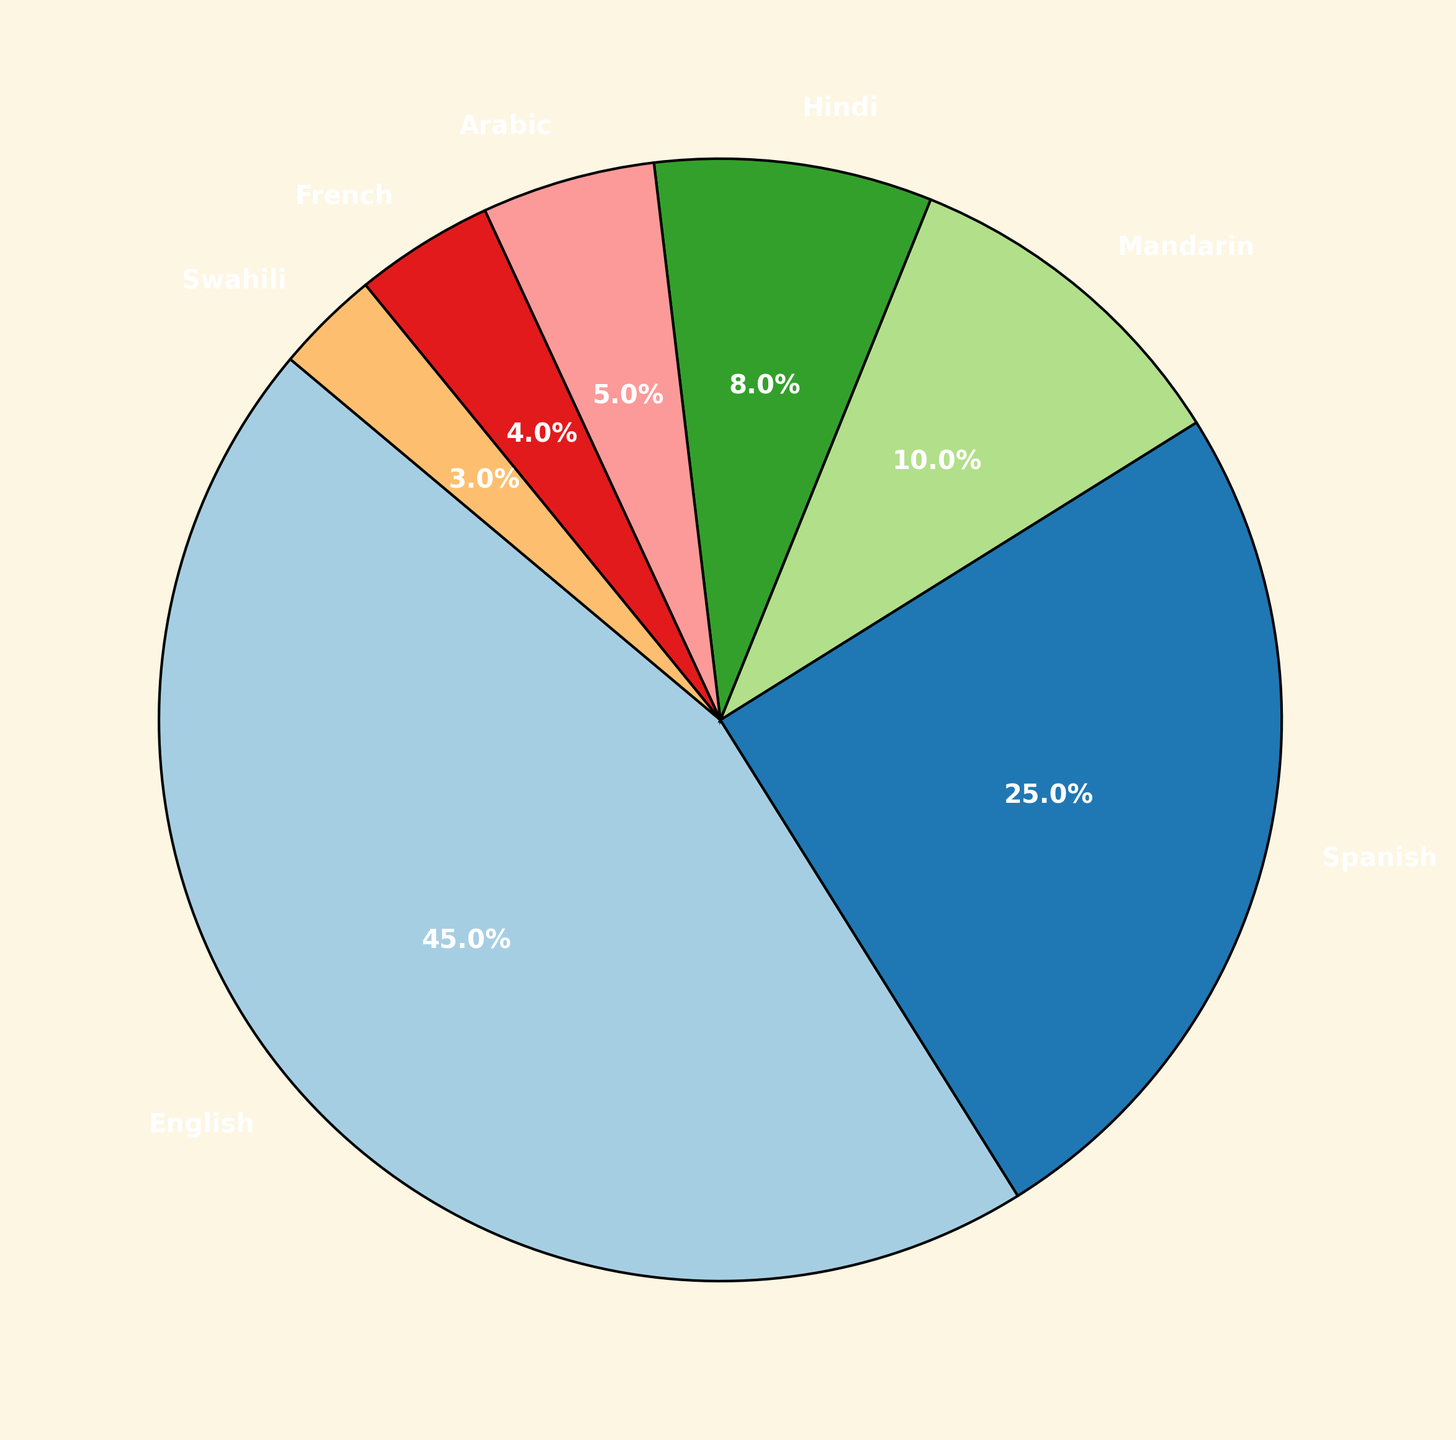What's the most frequently used language in religious services? The pie chart shows the proportions of different languages used. English has the largest proportion slice.
Answer: English What's the least frequently used language in religious services? The pie chart shows the proportions of different languages used. Swahili has the smallest proportion slice.
Answer: Swahili What proportion of religious services are conducted in languages other than English and Spanish combined? The pie chart shows the proportions of different languages. Combining the proportions for Mandarin, Hindi, Arabic, French, and Swahili gives 10% + 8% + 5% + 4% + 3% = 30%.
Answer: 30% How does the proportion of Spanish compare to the proportion of Hindi? By comparing the slices on the pie chart, Spanish has a larger proportion (25%) than Hindi (8%).
Answer: Spanish > Hindi What proportions of religious services are conducted in languages from Asia (Mandarin, Hindi, and Arabic) combined? The pie chart shows the proportions of Mandarin, Hindi, and Arabic. Adding these gives 10% + 8% + 5% = 23%.
Answer: 23% Which language is used 8% of the time in religious services? The pie chart shows Hindi occupying the slice marked as 8%.
Answer: Hindi How much larger is the proportion of English compared to Mandarin? The pie chart shows English at 45% and Mandarin at 10%. Subtract 10% from 45% to get the difference, which is 35%.
Answer: 35% What is the total proportion of religious services conducted in languages from Africa (Arabic and Swahili)? The pie chart shows the proportions of Arabic and Swahili. Adding these gives 5% + 3% = 8%.
Answer: 8% How does the use of French in religious services compare to the use of Swahili? By comparisons of the slices on the pie chart, French has a larger proportion (4%) than Swahili (3%).
Answer: French > Swahili Is the proportion of services conducted in Mandarin larger or smaller than the services conducted in French and Swahili combined? The pie chart shows Mandarin at 10%, French at 4%, and Swahili at 3%. Combined, French and Swahili have 4% + 3% = 7%. Since 10% is greater than 7%, Mandarin is larger.
Answer: Larger 